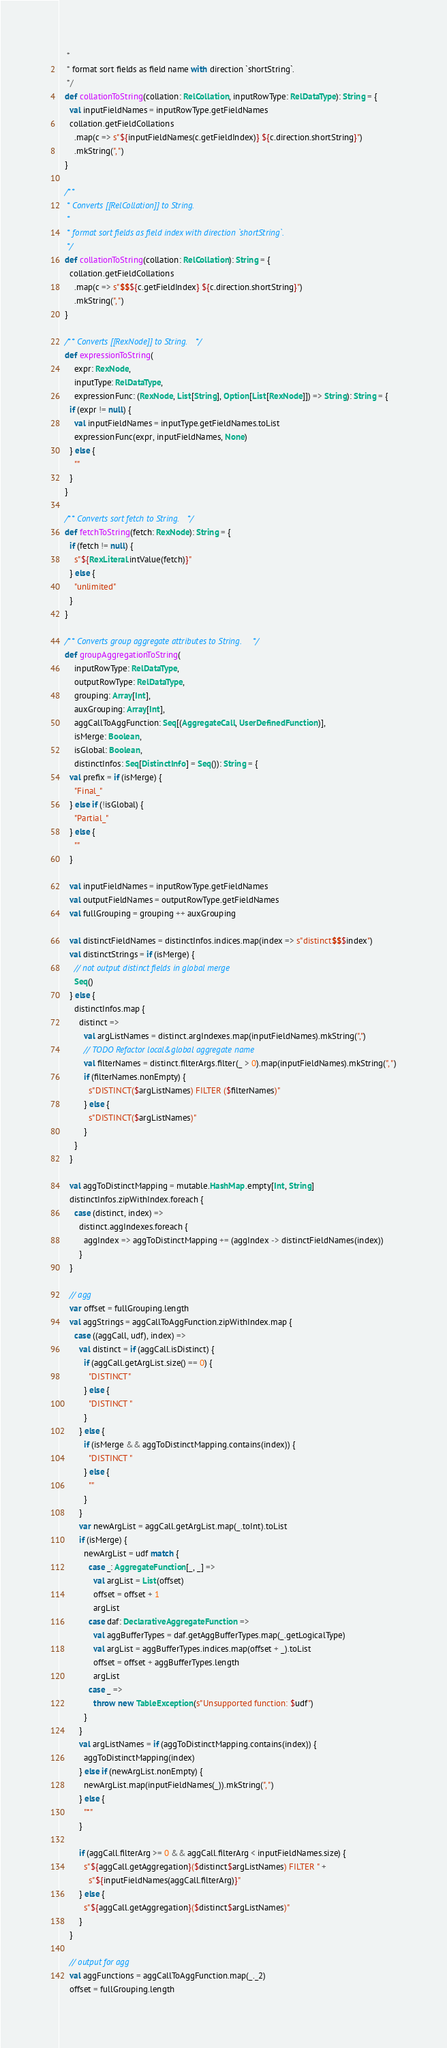Convert code to text. <code><loc_0><loc_0><loc_500><loc_500><_Scala_>   *
   * format sort fields as field name with direction `shortString`.
   */
  def collationToString(collation: RelCollation, inputRowType: RelDataType): String = {
    val inputFieldNames = inputRowType.getFieldNames
    collation.getFieldCollations
      .map(c => s"${inputFieldNames(c.getFieldIndex)} ${c.direction.shortString}")
      .mkString(", ")
  }

  /**
   * Converts [[RelCollation]] to String.
   *
   * format sort fields as field index with direction `shortString`.
   */
  def collationToString(collation: RelCollation): String = {
    collation.getFieldCollations
      .map(c => s"$$${c.getFieldIndex} ${c.direction.shortString}")
      .mkString(", ")
  }

  /** Converts [[RexNode]] to String. */
  def expressionToString(
      expr: RexNode,
      inputType: RelDataType,
      expressionFunc: (RexNode, List[String], Option[List[RexNode]]) => String): String = {
    if (expr != null) {
      val inputFieldNames = inputType.getFieldNames.toList
      expressionFunc(expr, inputFieldNames, None)
    } else {
      ""
    }
  }

  /** Converts sort fetch to String. */
  def fetchToString(fetch: RexNode): String = {
    if (fetch != null) {
      s"${RexLiteral.intValue(fetch)}"
    } else {
      "unlimited"
    }
  }

  /** Converts group aggregate attributes to String. */
  def groupAggregationToString(
      inputRowType: RelDataType,
      outputRowType: RelDataType,
      grouping: Array[Int],
      auxGrouping: Array[Int],
      aggCallToAggFunction: Seq[(AggregateCall, UserDefinedFunction)],
      isMerge: Boolean,
      isGlobal: Boolean,
      distinctInfos: Seq[DistinctInfo] = Seq()): String = {
    val prefix = if (isMerge) {
      "Final_"
    } else if (!isGlobal) {
      "Partial_"
    } else {
      ""
    }

    val inputFieldNames = inputRowType.getFieldNames
    val outputFieldNames = outputRowType.getFieldNames
    val fullGrouping = grouping ++ auxGrouping

    val distinctFieldNames = distinctInfos.indices.map(index => s"distinct$$$index")
    val distinctStrings = if (isMerge) {
      // not output distinct fields in global merge
      Seq()
    } else {
      distinctInfos.map {
        distinct =>
          val argListNames = distinct.argIndexes.map(inputFieldNames).mkString(",")
          // TODO Refactor local&global aggregate name
          val filterNames = distinct.filterArgs.filter(_ > 0).map(inputFieldNames).mkString(", ")
          if (filterNames.nonEmpty) {
            s"DISTINCT($argListNames) FILTER ($filterNames)"
          } else {
            s"DISTINCT($argListNames)"
          }
      }
    }

    val aggToDistinctMapping = mutable.HashMap.empty[Int, String]
    distinctInfos.zipWithIndex.foreach {
      case (distinct, index) =>
        distinct.aggIndexes.foreach {
          aggIndex => aggToDistinctMapping += (aggIndex -> distinctFieldNames(index))
        }
    }

    // agg
    var offset = fullGrouping.length
    val aggStrings = aggCallToAggFunction.zipWithIndex.map {
      case ((aggCall, udf), index) =>
        val distinct = if (aggCall.isDistinct) {
          if (aggCall.getArgList.size() == 0) {
            "DISTINCT"
          } else {
            "DISTINCT "
          }
        } else {
          if (isMerge && aggToDistinctMapping.contains(index)) {
            "DISTINCT "
          } else {
            ""
          }
        }
        var newArgList = aggCall.getArgList.map(_.toInt).toList
        if (isMerge) {
          newArgList = udf match {
            case _: AggregateFunction[_, _] =>
              val argList = List(offset)
              offset = offset + 1
              argList
            case daf: DeclarativeAggregateFunction =>
              val aggBufferTypes = daf.getAggBufferTypes.map(_.getLogicalType)
              val argList = aggBufferTypes.indices.map(offset + _).toList
              offset = offset + aggBufferTypes.length
              argList
            case _ =>
              throw new TableException(s"Unsupported function: $udf")
          }
        }
        val argListNames = if (aggToDistinctMapping.contains(index)) {
          aggToDistinctMapping(index)
        } else if (newArgList.nonEmpty) {
          newArgList.map(inputFieldNames(_)).mkString(", ")
        } else {
          "*"
        }

        if (aggCall.filterArg >= 0 && aggCall.filterArg < inputFieldNames.size) {
          s"${aggCall.getAggregation}($distinct$argListNames) FILTER " +
            s"${inputFieldNames(aggCall.filterArg)}"
        } else {
          s"${aggCall.getAggregation}($distinct$argListNames)"
        }
    }

    // output for agg
    val aggFunctions = aggCallToAggFunction.map(_._2)
    offset = fullGrouping.length</code> 